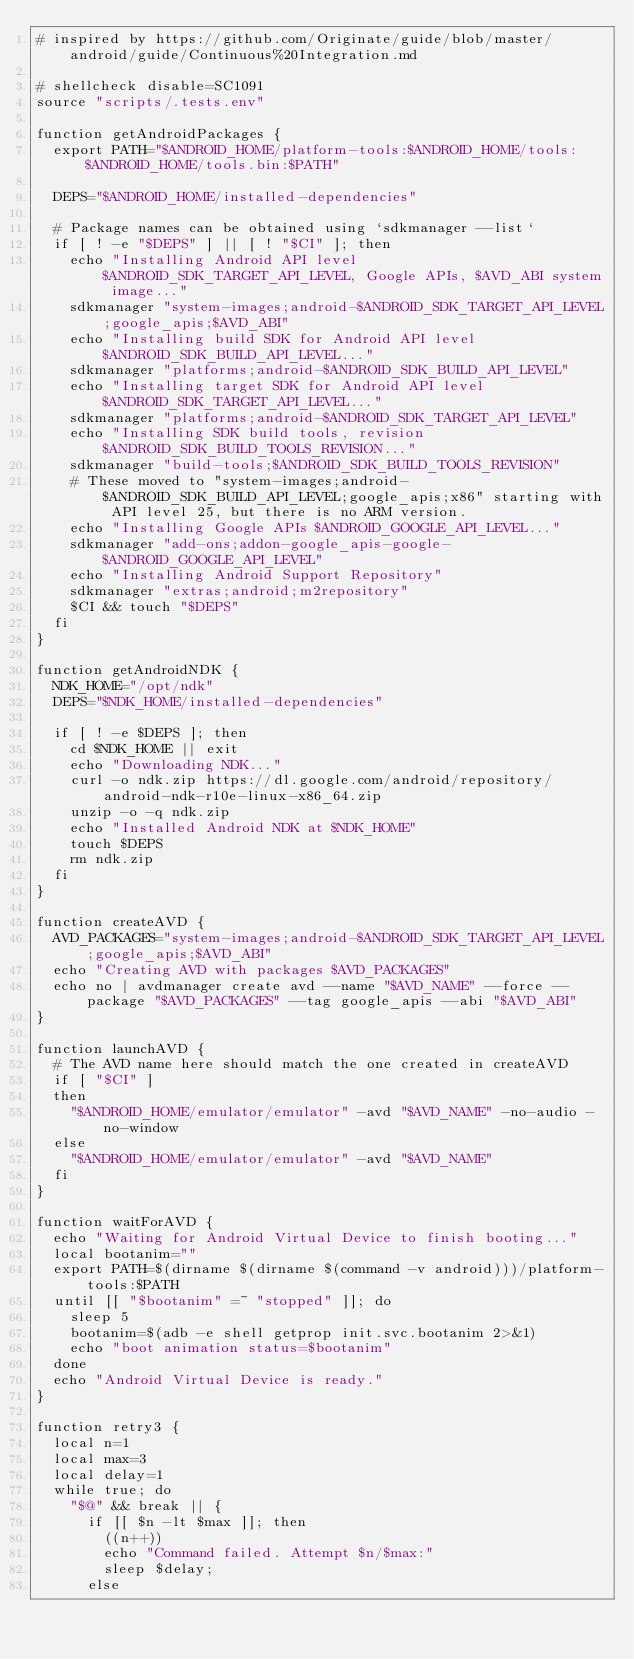<code> <loc_0><loc_0><loc_500><loc_500><_Bash_># inspired by https://github.com/Originate/guide/blob/master/android/guide/Continuous%20Integration.md

# shellcheck disable=SC1091
source "scripts/.tests.env"

function getAndroidPackages {
  export PATH="$ANDROID_HOME/platform-tools:$ANDROID_HOME/tools:$ANDROID_HOME/tools.bin:$PATH"

  DEPS="$ANDROID_HOME/installed-dependencies"

  # Package names can be obtained using `sdkmanager --list`
  if [ ! -e "$DEPS" ] || [ ! "$CI" ]; then
    echo "Installing Android API level $ANDROID_SDK_TARGET_API_LEVEL, Google APIs, $AVD_ABI system image..."
    sdkmanager "system-images;android-$ANDROID_SDK_TARGET_API_LEVEL;google_apis;$AVD_ABI"
    echo "Installing build SDK for Android API level $ANDROID_SDK_BUILD_API_LEVEL..."
    sdkmanager "platforms;android-$ANDROID_SDK_BUILD_API_LEVEL"
    echo "Installing target SDK for Android API level $ANDROID_SDK_TARGET_API_LEVEL..."
    sdkmanager "platforms;android-$ANDROID_SDK_TARGET_API_LEVEL"
    echo "Installing SDK build tools, revision $ANDROID_SDK_BUILD_TOOLS_REVISION..."
    sdkmanager "build-tools;$ANDROID_SDK_BUILD_TOOLS_REVISION"
    # These moved to "system-images;android-$ANDROID_SDK_BUILD_API_LEVEL;google_apis;x86" starting with API level 25, but there is no ARM version.
    echo "Installing Google APIs $ANDROID_GOOGLE_API_LEVEL..."
    sdkmanager "add-ons;addon-google_apis-google-$ANDROID_GOOGLE_API_LEVEL"
    echo "Installing Android Support Repository"
    sdkmanager "extras;android;m2repository"
    $CI && touch "$DEPS"
  fi
}

function getAndroidNDK {
  NDK_HOME="/opt/ndk"
  DEPS="$NDK_HOME/installed-dependencies"

  if [ ! -e $DEPS ]; then
    cd $NDK_HOME || exit
    echo "Downloading NDK..."
    curl -o ndk.zip https://dl.google.com/android/repository/android-ndk-r10e-linux-x86_64.zip
    unzip -o -q ndk.zip
    echo "Installed Android NDK at $NDK_HOME"
    touch $DEPS
    rm ndk.zip
  fi
}

function createAVD {
  AVD_PACKAGES="system-images;android-$ANDROID_SDK_TARGET_API_LEVEL;google_apis;$AVD_ABI"
  echo "Creating AVD with packages $AVD_PACKAGES"
  echo no | avdmanager create avd --name "$AVD_NAME" --force --package "$AVD_PACKAGES" --tag google_apis --abi "$AVD_ABI"
}

function launchAVD {
  # The AVD name here should match the one created in createAVD
  if [ "$CI" ]
  then
    "$ANDROID_HOME/emulator/emulator" -avd "$AVD_NAME" -no-audio -no-window
  else
    "$ANDROID_HOME/emulator/emulator" -avd "$AVD_NAME"
  fi
}

function waitForAVD {
  echo "Waiting for Android Virtual Device to finish booting..."
  local bootanim=""
  export PATH=$(dirname $(dirname $(command -v android)))/platform-tools:$PATH
  until [[ "$bootanim" =~ "stopped" ]]; do
    sleep 5
    bootanim=$(adb -e shell getprop init.svc.bootanim 2>&1)
    echo "boot animation status=$bootanim"
  done
  echo "Android Virtual Device is ready."
}

function retry3 {
  local n=1
  local max=3
  local delay=1
  while true; do
    "$@" && break || {
      if [[ $n -lt $max ]]; then
        ((n++))
        echo "Command failed. Attempt $n/$max:"
        sleep $delay;
      else</code> 